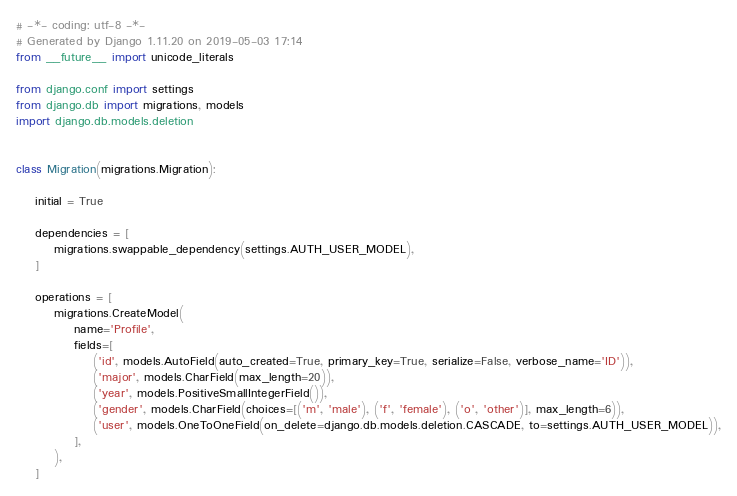Convert code to text. <code><loc_0><loc_0><loc_500><loc_500><_Python_># -*- coding: utf-8 -*-
# Generated by Django 1.11.20 on 2019-05-03 17:14
from __future__ import unicode_literals

from django.conf import settings
from django.db import migrations, models
import django.db.models.deletion


class Migration(migrations.Migration):

    initial = True

    dependencies = [
        migrations.swappable_dependency(settings.AUTH_USER_MODEL),
    ]

    operations = [
        migrations.CreateModel(
            name='Profile',
            fields=[
                ('id', models.AutoField(auto_created=True, primary_key=True, serialize=False, verbose_name='ID')),
                ('major', models.CharField(max_length=20)),
                ('year', models.PositiveSmallIntegerField()),
                ('gender', models.CharField(choices=[('m', 'male'), ('f', 'female'), ('o', 'other')], max_length=6)),
                ('user', models.OneToOneField(on_delete=django.db.models.deletion.CASCADE, to=settings.AUTH_USER_MODEL)),
            ],
        ),
    ]
</code> 